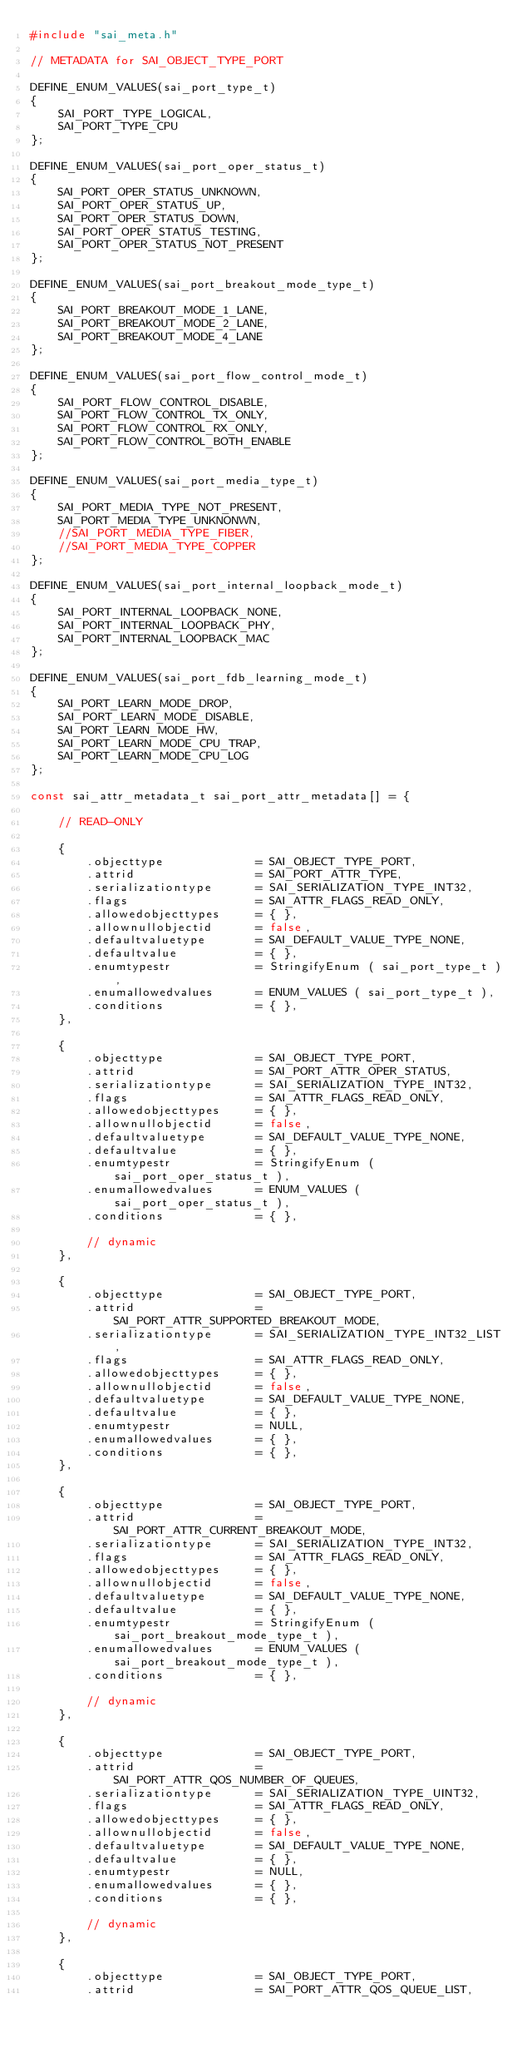<code> <loc_0><loc_0><loc_500><loc_500><_C++_>#include "sai_meta.h"

// METADATA for SAI_OBJECT_TYPE_PORT

DEFINE_ENUM_VALUES(sai_port_type_t)
{
    SAI_PORT_TYPE_LOGICAL,
    SAI_PORT_TYPE_CPU
};

DEFINE_ENUM_VALUES(sai_port_oper_status_t)
{
    SAI_PORT_OPER_STATUS_UNKNOWN,
    SAI_PORT_OPER_STATUS_UP,
    SAI_PORT_OPER_STATUS_DOWN,
    SAI_PORT_OPER_STATUS_TESTING,
    SAI_PORT_OPER_STATUS_NOT_PRESENT
};

DEFINE_ENUM_VALUES(sai_port_breakout_mode_type_t)
{
    SAI_PORT_BREAKOUT_MODE_1_LANE,
    SAI_PORT_BREAKOUT_MODE_2_LANE,
    SAI_PORT_BREAKOUT_MODE_4_LANE
};

DEFINE_ENUM_VALUES(sai_port_flow_control_mode_t)
{
    SAI_PORT_FLOW_CONTROL_DISABLE,
    SAI_PORT_FLOW_CONTROL_TX_ONLY,
    SAI_PORT_FLOW_CONTROL_RX_ONLY,
    SAI_PORT_FLOW_CONTROL_BOTH_ENABLE
};

DEFINE_ENUM_VALUES(sai_port_media_type_t)
{
    SAI_PORT_MEDIA_TYPE_NOT_PRESENT,
    SAI_PORT_MEDIA_TYPE_UNKNONWN,
    //SAI_PORT_MEDIA_TYPE_FIBER,
    //SAI_PORT_MEDIA_TYPE_COPPER
};

DEFINE_ENUM_VALUES(sai_port_internal_loopback_mode_t)
{
    SAI_PORT_INTERNAL_LOOPBACK_NONE,
    SAI_PORT_INTERNAL_LOOPBACK_PHY,
    SAI_PORT_INTERNAL_LOOPBACK_MAC
};

DEFINE_ENUM_VALUES(sai_port_fdb_learning_mode_t)
{
    SAI_PORT_LEARN_MODE_DROP,
    SAI_PORT_LEARN_MODE_DISABLE,
    SAI_PORT_LEARN_MODE_HW,
    SAI_PORT_LEARN_MODE_CPU_TRAP,
    SAI_PORT_LEARN_MODE_CPU_LOG
};

const sai_attr_metadata_t sai_port_attr_metadata[] = {

    // READ-ONLY

    {
        .objecttype             = SAI_OBJECT_TYPE_PORT,
        .attrid                 = SAI_PORT_ATTR_TYPE,
        .serializationtype      = SAI_SERIALIZATION_TYPE_INT32,
        .flags                  = SAI_ATTR_FLAGS_READ_ONLY,
        .allowedobjecttypes     = { },
        .allownullobjectid      = false,
        .defaultvaluetype       = SAI_DEFAULT_VALUE_TYPE_NONE,
        .defaultvalue           = { },
        .enumtypestr            = StringifyEnum ( sai_port_type_t ),
        .enumallowedvalues      = ENUM_VALUES ( sai_port_type_t ),
        .conditions             = { },
    },

    {
        .objecttype             = SAI_OBJECT_TYPE_PORT,
        .attrid                 = SAI_PORT_ATTR_OPER_STATUS,
        .serializationtype      = SAI_SERIALIZATION_TYPE_INT32,
        .flags                  = SAI_ATTR_FLAGS_READ_ONLY,
        .allowedobjecttypes     = { },
        .allownullobjectid      = false,
        .defaultvaluetype       = SAI_DEFAULT_VALUE_TYPE_NONE,
        .defaultvalue           = { },
        .enumtypestr            = StringifyEnum ( sai_port_oper_status_t ),
        .enumallowedvalues      = ENUM_VALUES ( sai_port_oper_status_t ),
        .conditions             = { },

        // dynamic
    },

    {
        .objecttype             = SAI_OBJECT_TYPE_PORT,
        .attrid                 = SAI_PORT_ATTR_SUPPORTED_BREAKOUT_MODE,
        .serializationtype      = SAI_SERIALIZATION_TYPE_INT32_LIST,
        .flags                  = SAI_ATTR_FLAGS_READ_ONLY,
        .allowedobjecttypes     = { },
        .allownullobjectid      = false,
        .defaultvaluetype       = SAI_DEFAULT_VALUE_TYPE_NONE,
        .defaultvalue           = { },
        .enumtypestr            = NULL,
        .enumallowedvalues      = { },
        .conditions             = { },
    },

    {
        .objecttype             = SAI_OBJECT_TYPE_PORT,
        .attrid                 = SAI_PORT_ATTR_CURRENT_BREAKOUT_MODE,
        .serializationtype      = SAI_SERIALIZATION_TYPE_INT32,
        .flags                  = SAI_ATTR_FLAGS_READ_ONLY,
        .allowedobjecttypes     = { },
        .allownullobjectid      = false,
        .defaultvaluetype       = SAI_DEFAULT_VALUE_TYPE_NONE,
        .defaultvalue           = { },
        .enumtypestr            = StringifyEnum ( sai_port_breakout_mode_type_t ),
        .enumallowedvalues      = ENUM_VALUES ( sai_port_breakout_mode_type_t ),
        .conditions             = { },

        // dynamic
    },

    {
        .objecttype             = SAI_OBJECT_TYPE_PORT,
        .attrid                 = SAI_PORT_ATTR_QOS_NUMBER_OF_QUEUES,
        .serializationtype      = SAI_SERIALIZATION_TYPE_UINT32,
        .flags                  = SAI_ATTR_FLAGS_READ_ONLY,
        .allowedobjecttypes     = { },
        .allownullobjectid      = false,
        .defaultvaluetype       = SAI_DEFAULT_VALUE_TYPE_NONE,
        .defaultvalue           = { },
        .enumtypestr            = NULL,
        .enumallowedvalues      = { },
        .conditions             = { },

        // dynamic
    },

    {
        .objecttype             = SAI_OBJECT_TYPE_PORT,
        .attrid                 = SAI_PORT_ATTR_QOS_QUEUE_LIST,</code> 